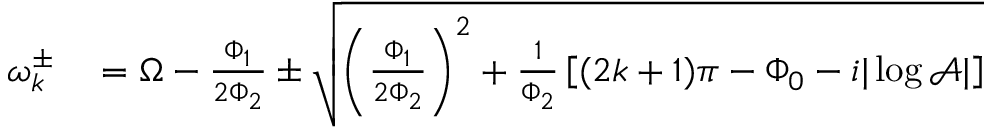<formula> <loc_0><loc_0><loc_500><loc_500>\begin{array} { r l } { \omega _ { k } ^ { \pm } } & = \Omega - \frac { \Phi _ { 1 } } { 2 \Phi _ { 2 } } \pm \sqrt { \left ( \frac { \Phi _ { 1 } } { 2 \Phi _ { 2 } } \right ) ^ { 2 } + \frac { 1 } { \Phi _ { 2 } } \left [ ( 2 k + 1 ) \pi - \Phi _ { 0 } - i | \log \mathcal { A } | \right ] } } \end{array}</formula> 